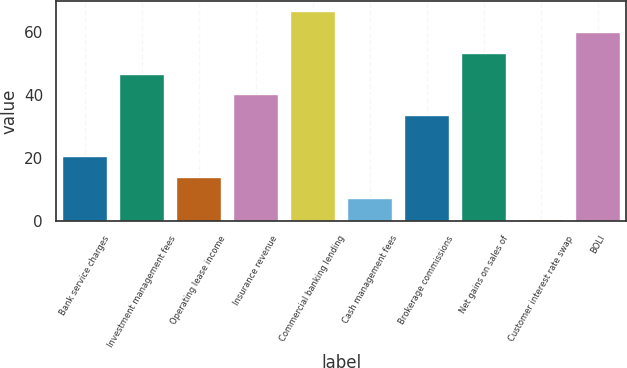<chart> <loc_0><loc_0><loc_500><loc_500><bar_chart><fcel>Bank service charges<fcel>Investment management fees<fcel>Operating lease income<fcel>Insurance revenue<fcel>Commercial banking lending<fcel>Cash management fees<fcel>Brokerage commissions<fcel>Net gains on sales of<fcel>Customer interest rate swap<fcel>BOLI<nl><fcel>20.5<fcel>46.9<fcel>13.9<fcel>40.3<fcel>66.7<fcel>7.3<fcel>33.7<fcel>53.5<fcel>0.7<fcel>60.1<nl></chart> 